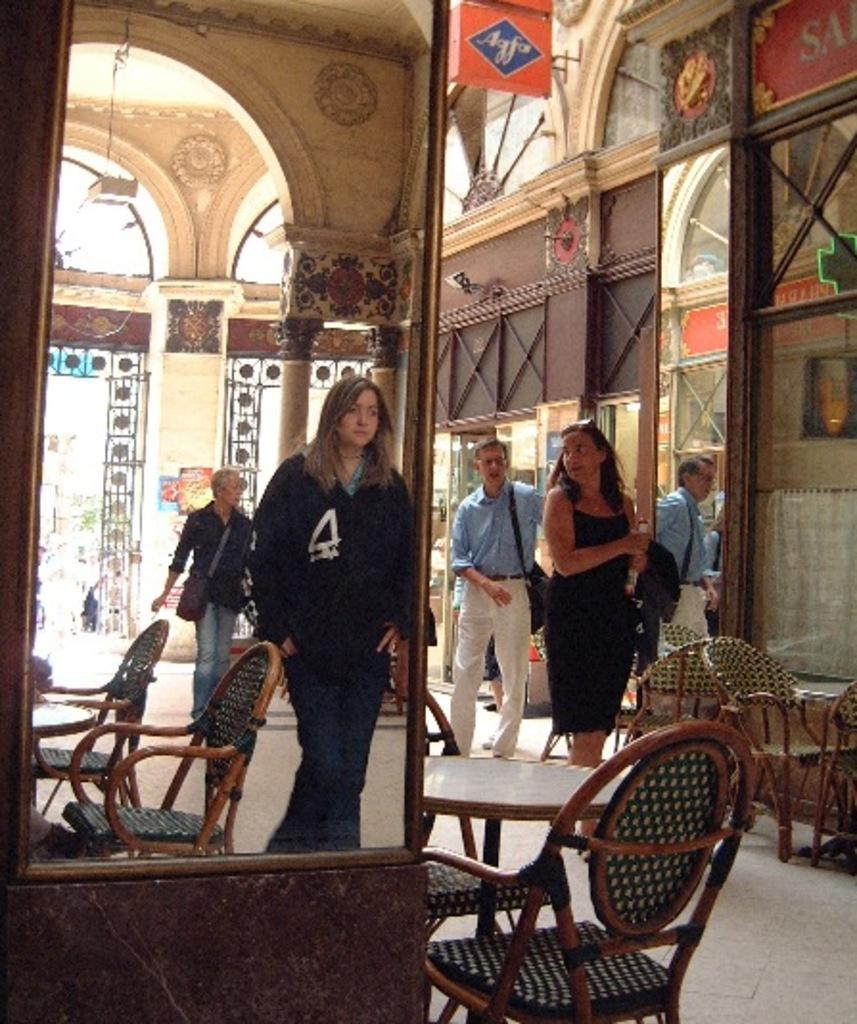How many persons can be seen in the image? There are persons standing in the image. What surface are the persons standing on? The persons are standing on the floor. What type of furniture is present in the image? There are chairs and a table in the image. What reflective object is present in the image? There is a mirror in the image. What architectural feature can be seen in the image? There is a pillar in the image. What type of animals can be seen in the zoo in the image? There is no zoo present in the image; it features persons standing, chairs, a table, a mirror, and a pillar. What type of doll is sitting on the chair in the image? There is no doll present in the image; it features persons standing, chairs, a table, a mirror, and a pillar. 